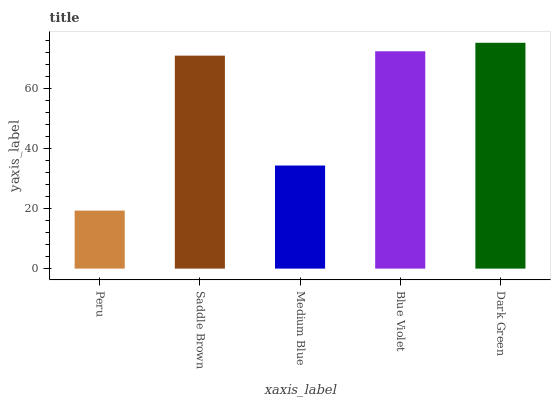Is Peru the minimum?
Answer yes or no. Yes. Is Dark Green the maximum?
Answer yes or no. Yes. Is Saddle Brown the minimum?
Answer yes or no. No. Is Saddle Brown the maximum?
Answer yes or no. No. Is Saddle Brown greater than Peru?
Answer yes or no. Yes. Is Peru less than Saddle Brown?
Answer yes or no. Yes. Is Peru greater than Saddle Brown?
Answer yes or no. No. Is Saddle Brown less than Peru?
Answer yes or no. No. Is Saddle Brown the high median?
Answer yes or no. Yes. Is Saddle Brown the low median?
Answer yes or no. Yes. Is Medium Blue the high median?
Answer yes or no. No. Is Blue Violet the low median?
Answer yes or no. No. 